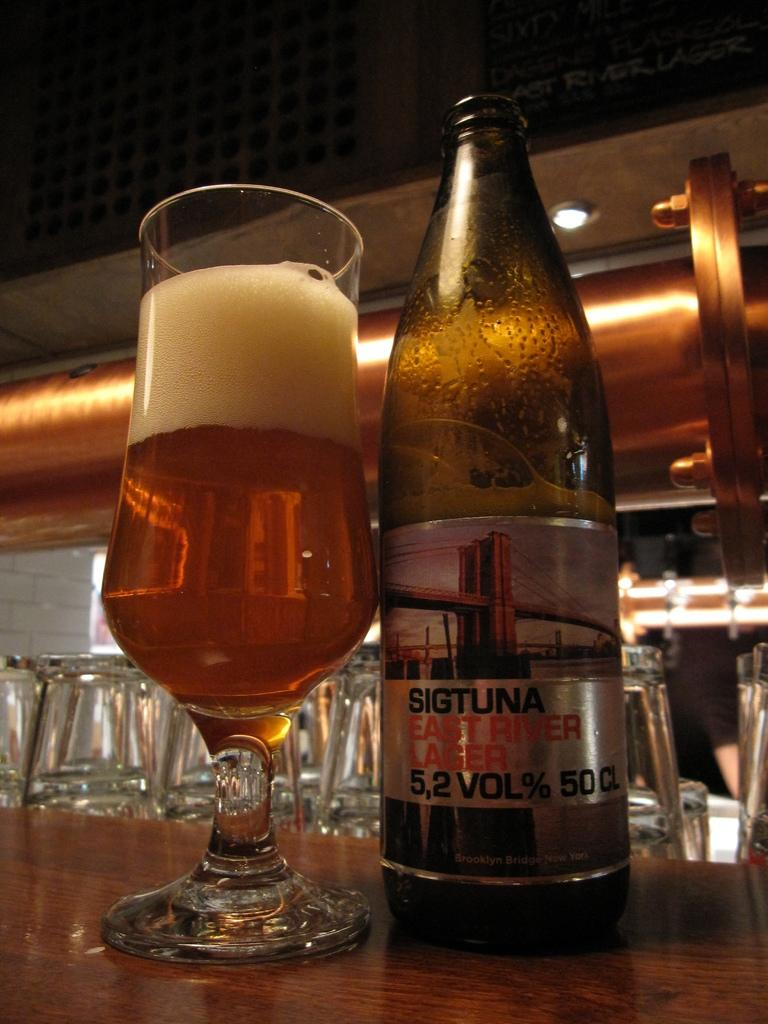<image>
Present a compact description of the photo's key features. A bottle of Sigtuna East River Lager with a full glass of beer. 